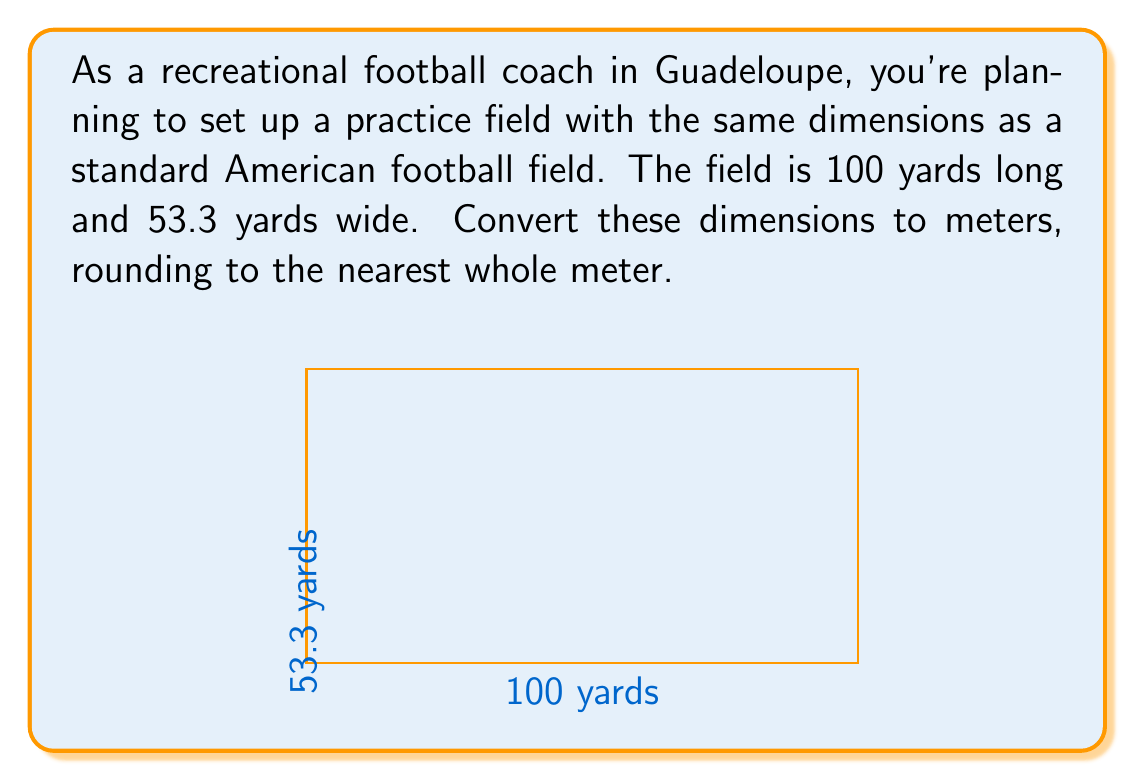Show me your answer to this math problem. To convert yards to meters, we'll use the conversion factor: 1 yard = 0.9144 meters

1. Convert the length:
   $100 \text{ yards} \times 0.9144 \text{ meters/yard} = 91.44 \text{ meters}$
   Rounded to the nearest whole meter: 91 meters

2. Convert the width:
   $53.3 \text{ yards} \times 0.9144 \text{ meters/yard} = 48.73752 \text{ meters}$
   Rounded to the nearest whole meter: 49 meters

Therefore, the dimensions of the field in meters are 91 meters long and 49 meters wide.
Answer: 91 m × 49 m 